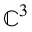<formula> <loc_0><loc_0><loc_500><loc_500>\mathbb { C } ^ { 3 }</formula> 